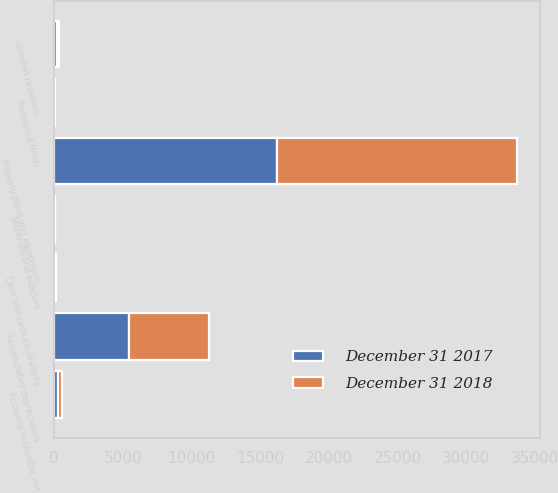Convert chart. <chart><loc_0><loc_0><loc_500><loc_500><stacked_bar_chart><ecel><fcel>Property plant and equipment<fcel>Accumulated depreciation<fcel>Cash and cash equivalents<fcel>Restricted funds<fcel>Accounts receivable net<fcel>Unbilled revenues<fcel>Materials and supplies<nl><fcel>December 31 2018<fcel>17409<fcel>5795<fcel>130<fcel>28<fcel>301<fcel>186<fcel>41<nl><fcel>December 31 2017<fcel>16246<fcel>5470<fcel>55<fcel>27<fcel>272<fcel>212<fcel>41<nl></chart> 